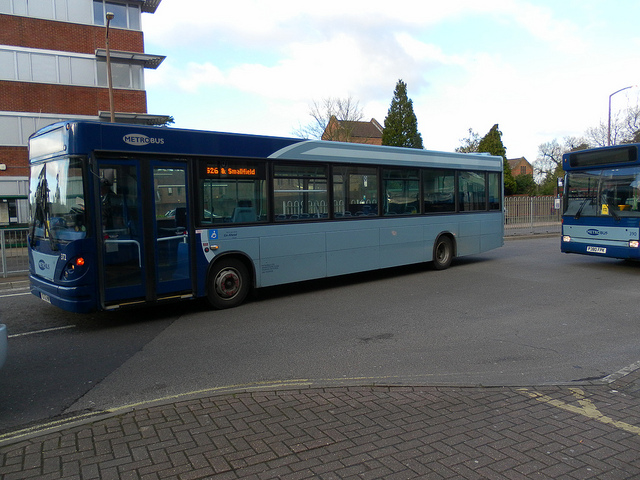<image>What does this bus run on? It's unknown what this bus runs on. It could be gas, diesel or compressed natural gas. What does this bus run on? I don't know what this bus runs on. It can be either gas, diesel, compressed natural gas, or fuel. 